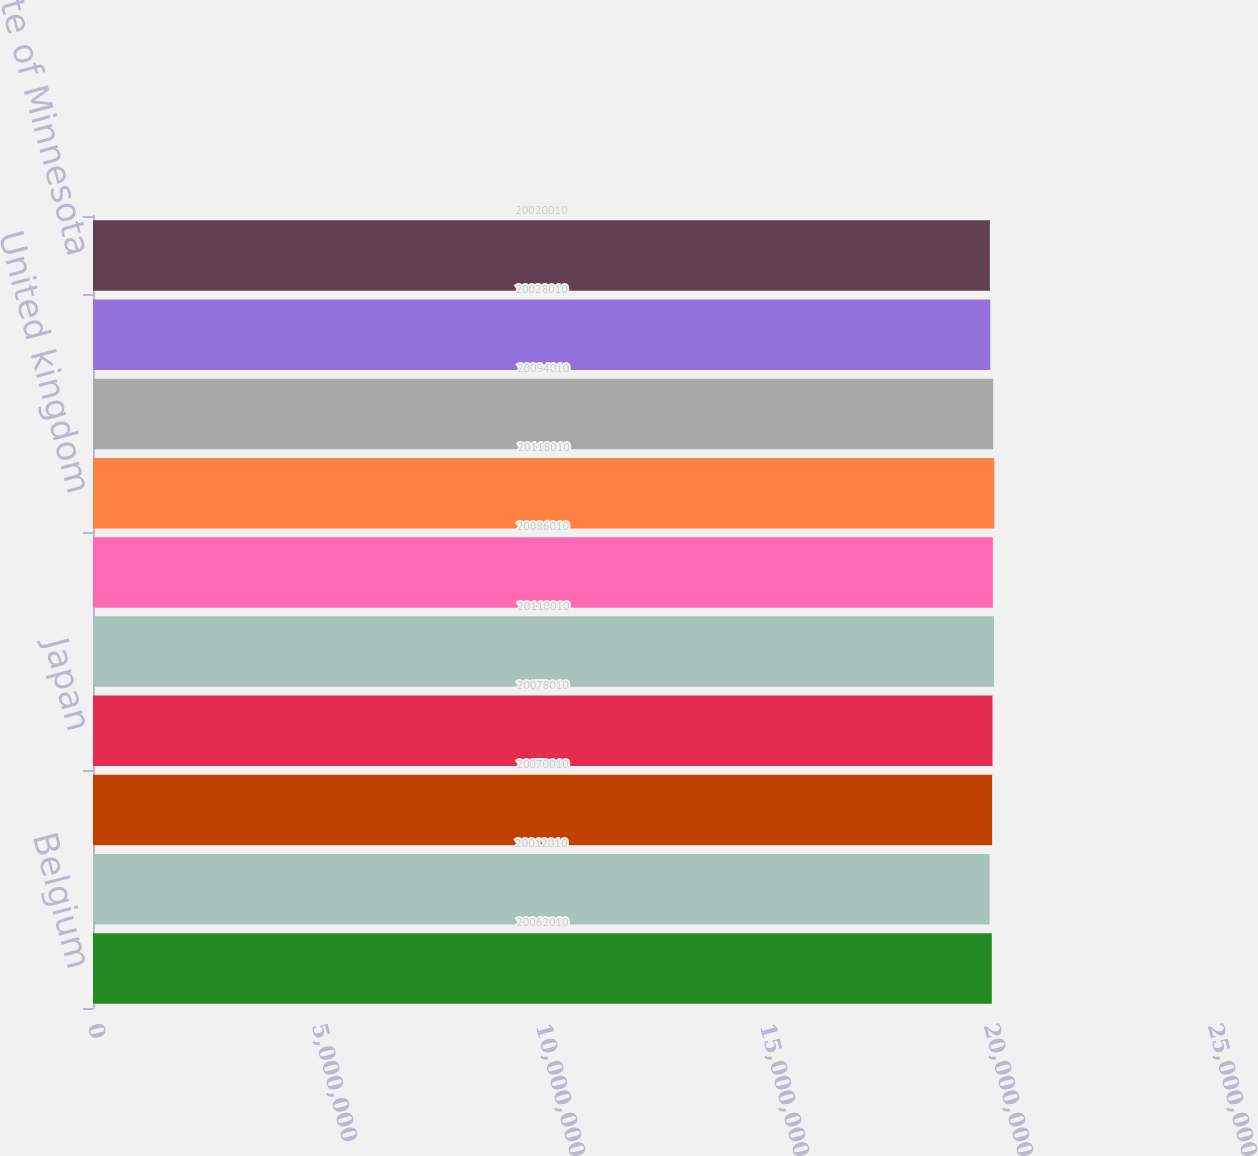<chart> <loc_0><loc_0><loc_500><loc_500><bar_chart><fcel>Belgium<fcel>Canada<fcel>France<fcel>Japan<fcel>korea<fcel>Switzerland<fcel>United kingdom<fcel>United States<fcel>State of California<fcel>State of Minnesota<nl><fcel>2.0062e+07<fcel>2.0012e+07<fcel>2.007e+07<fcel>2.0078e+07<fcel>2.011e+07<fcel>2.0086e+07<fcel>2.0118e+07<fcel>2.0094e+07<fcel>2.0028e+07<fcel>2.002e+07<nl></chart> 